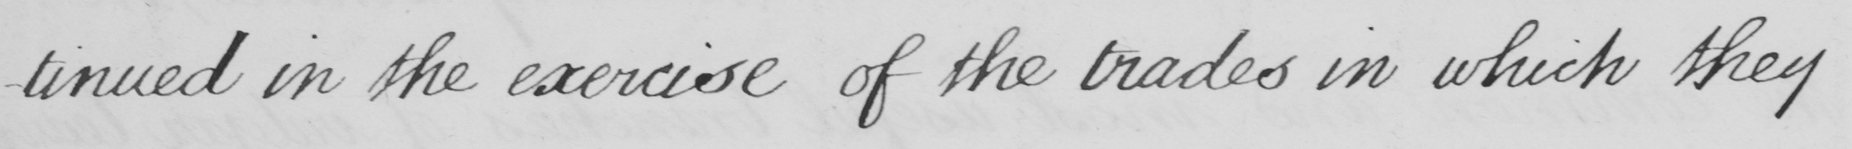Can you tell me what this handwritten text says? -tinued in the exercise of the trades in which they 